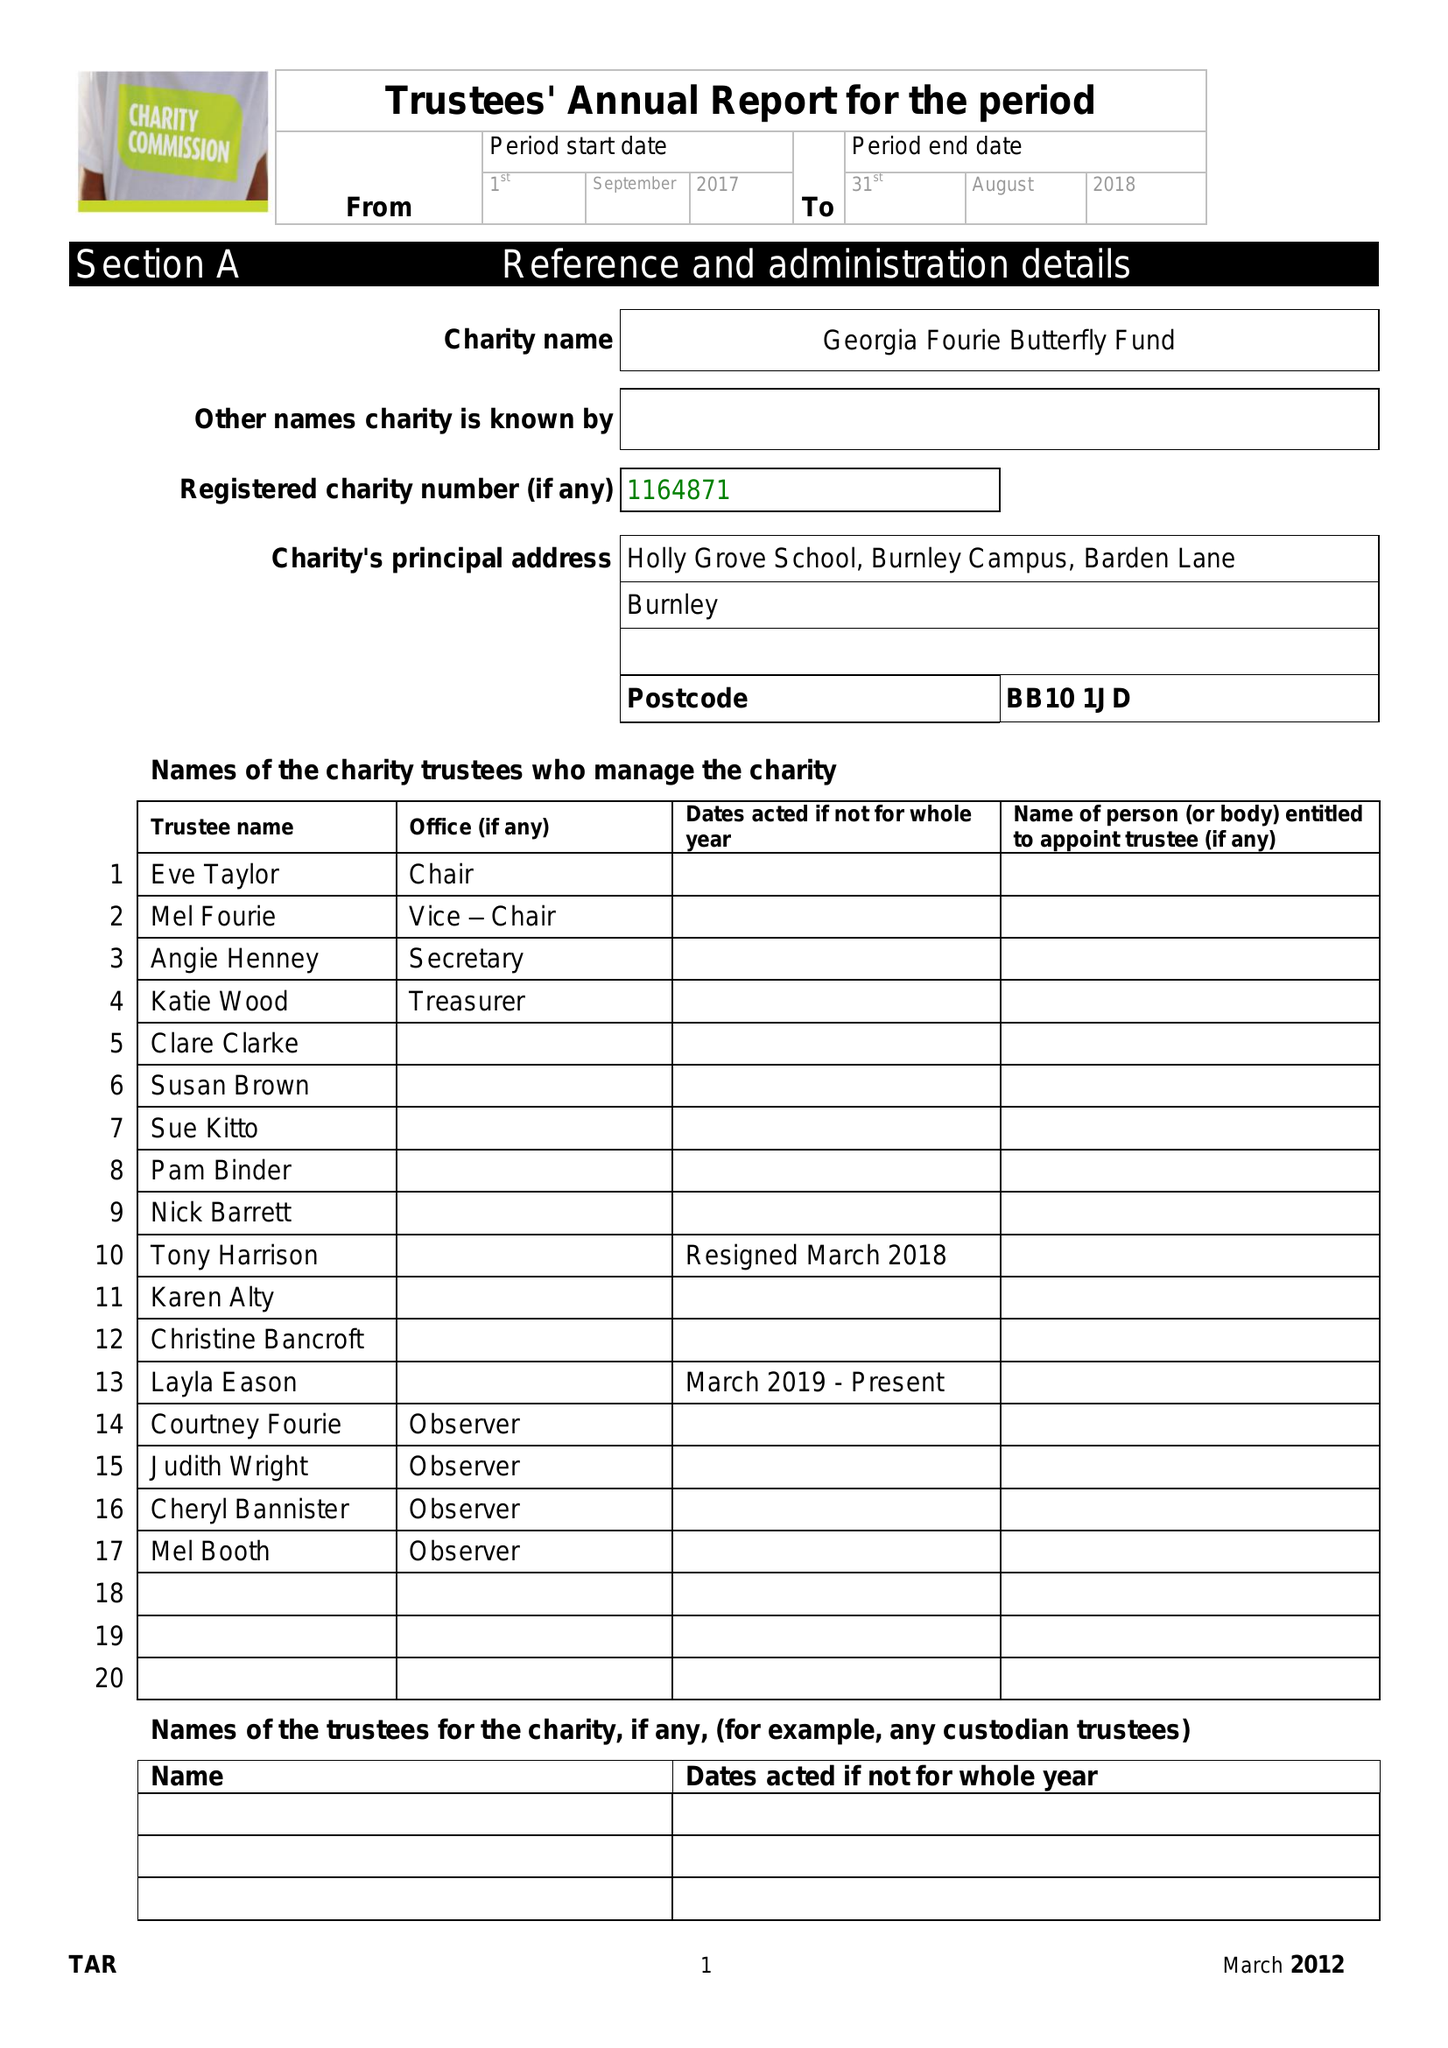What is the value for the charity_name?
Answer the question using a single word or phrase. The Georgia Fourie Butterfly Fund 